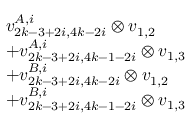<formula> <loc_0><loc_0><loc_500><loc_500>\begin{array} { r l } & { v _ { 2 k - 3 + 2 i , 4 k - 2 i } ^ { A , i } \otimes v _ { 1 , 2 } } \\ & { + v _ { 2 k - 3 + 2 i , 4 k - 1 - 2 i } ^ { A , i } \otimes v _ { 1 , 3 } } \\ & { + v _ { 2 k - 3 + 2 i , 4 k - 2 i } ^ { B , i } \otimes v _ { 1 , 2 } } \\ & { + v _ { 2 k - 3 + 2 i , 4 k - 1 - 2 i } ^ { B , i } \otimes v _ { 1 , 3 } } \end{array}</formula> 